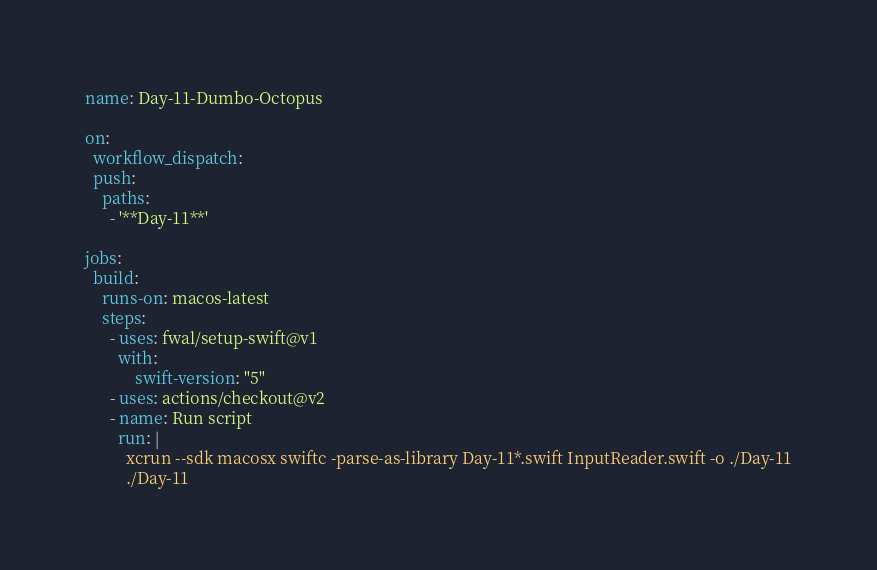<code> <loc_0><loc_0><loc_500><loc_500><_YAML_>name: Day-11-Dumbo-Octopus

on:
  workflow_dispatch:
  push:
    paths:
      - '**Day-11**'

jobs:
  build:
    runs-on: macos-latest
    steps:
      - uses: fwal/setup-swift@v1
        with:
            swift-version: "5"
      - uses: actions/checkout@v2
      - name: Run script
        run: |
          xcrun --sdk macosx swiftc -parse-as-library Day-11*.swift InputReader.swift -o ./Day-11
          ./Day-11
</code> 